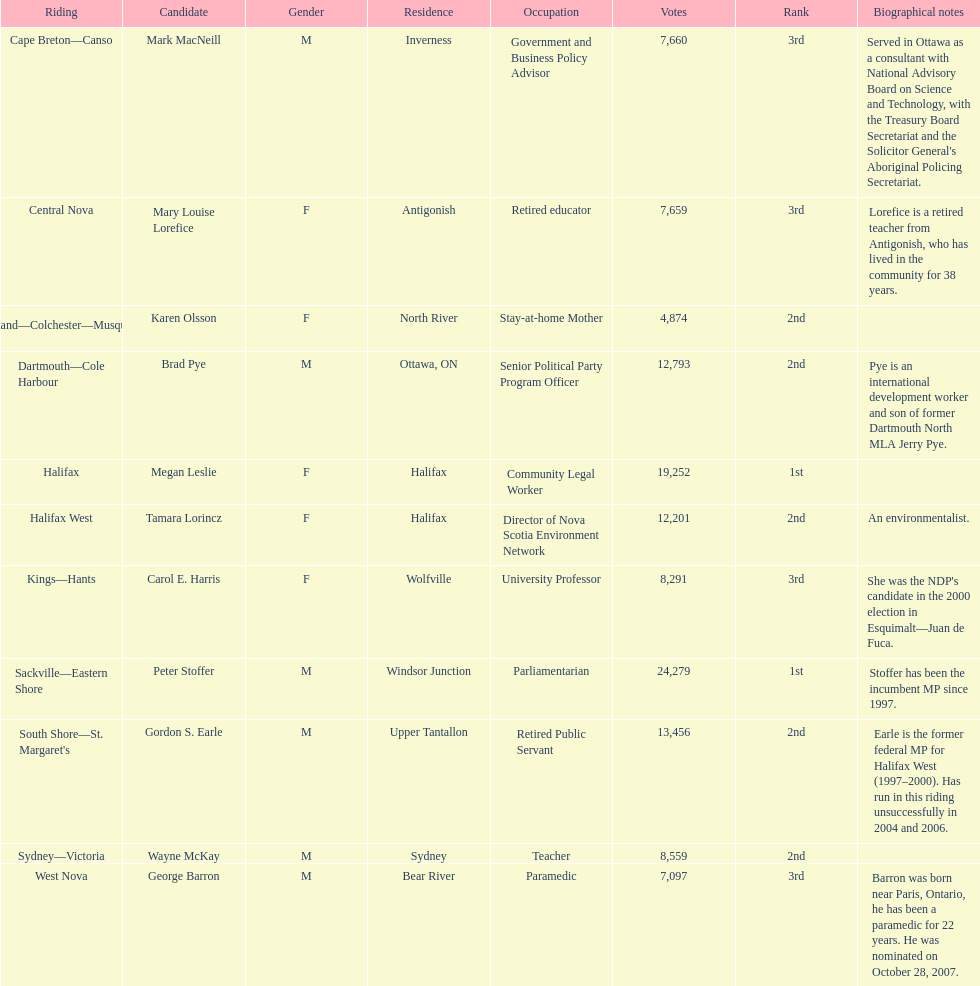Who were all of the new democratic party candidates during the 2008 canadian federal election? Mark MacNeill, Mary Louise Lorefice, Karen Olsson, Brad Pye, Megan Leslie, Tamara Lorincz, Carol E. Harris, Peter Stoffer, Gordon S. Earle, Wayne McKay, George Barron. And between mark macneill and karen olsson, which candidate received more votes? Mark MacNeill. 